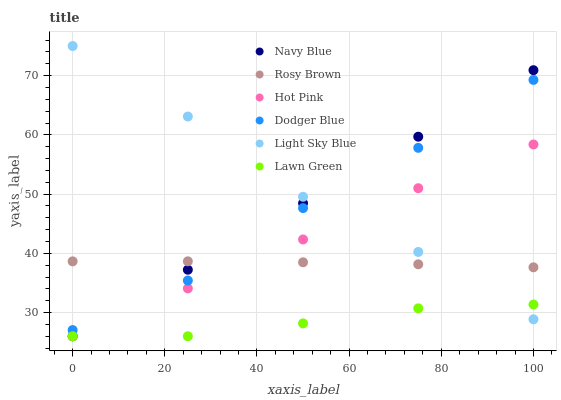Does Lawn Green have the minimum area under the curve?
Answer yes or no. Yes. Does Light Sky Blue have the maximum area under the curve?
Answer yes or no. Yes. Does Hot Pink have the minimum area under the curve?
Answer yes or no. No. Does Hot Pink have the maximum area under the curve?
Answer yes or no. No. Is Navy Blue the smoothest?
Answer yes or no. Yes. Is Light Sky Blue the roughest?
Answer yes or no. Yes. Is Hot Pink the smoothest?
Answer yes or no. No. Is Hot Pink the roughest?
Answer yes or no. No. Does Lawn Green have the lowest value?
Answer yes or no. Yes. Does Rosy Brown have the lowest value?
Answer yes or no. No. Does Light Sky Blue have the highest value?
Answer yes or no. Yes. Does Hot Pink have the highest value?
Answer yes or no. No. Is Lawn Green less than Dodger Blue?
Answer yes or no. Yes. Is Dodger Blue greater than Lawn Green?
Answer yes or no. Yes. Does Navy Blue intersect Dodger Blue?
Answer yes or no. Yes. Is Navy Blue less than Dodger Blue?
Answer yes or no. No. Is Navy Blue greater than Dodger Blue?
Answer yes or no. No. Does Lawn Green intersect Dodger Blue?
Answer yes or no. No. 